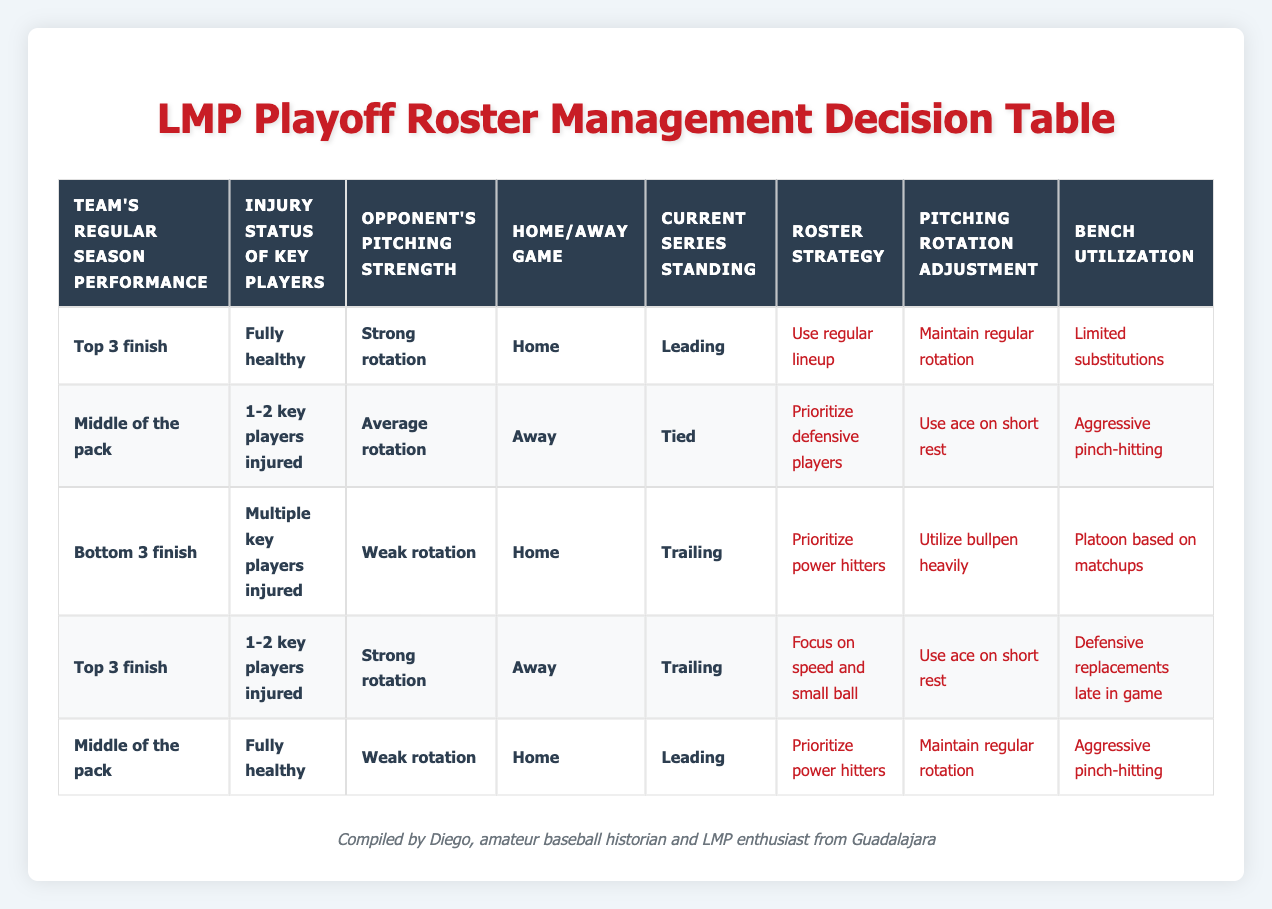What roster strategy is recommended for a team that finished in the Top 3 and is fully healthy at home while leading in the series? According to the table, the team that fits this description should "Use regular lineup." This matches with the row indicating a Top 3 finish, fully healthy players, home game, and leading in the series.
Answer: Use regular lineup What adjustments should a middle-of-the-pack team with 1-2 key players injured make while playing away and tied in the series? The table indicates that this team should "Prioritize defensive players," "Use ace on short rest," and "Aggressive pinch-hitting." This can be found in the corresponding row for the middle of the pack with key injuries, playing away and tied.
Answer: Prioritize defensive players; Use ace on short rest; Aggressive pinch-hitting Is it true that a team with a weak pitching rotation that finished in the Bottom 3 and has multiple key injuries should prioritize power hitters? Yes, the table confirms this. The relevant row shows that teams in that situation should "Prioritize power hitters," which matches the specified conditions.
Answer: Yes If a team is trailing in the series but has a Top 3 finish and 1-2 key players injured, what should they focus on? The strategy for this situation, as shown in the table, is to "Focus on speed and small ball" given they are trailing. This corresponds to the conditions described for that row.
Answer: Focus on speed and small ball What is the recommended pitching rotation adjustment for a team playing at home with a weak rotation while leading in the series? The table indicates that in this case, the adjustment should be to "Maintain regular rotation." This can be found under the middle of the pack with healthy players and leading at home.
Answer: Maintain regular rotation How many actions are listed for the scenario involving a trailing team in the Bottom 3 with multiple key injuries at home against a weak rotation? The table has 3 actions for this scenario: "Prioritize power hitters," "Utilize bullpen heavily," and "Platoon based on matchups." This means there are a total of three specific actions for this situation.
Answer: 3 actions What happens if a team that finished in the Middle of the pack is fully healthy, facing a strong rotation at home and is tied? The table suggests that they will need to "Prioritize defensive players," "Use ace on short rest," and "Aggressive pinch-hitting," as indicated by the corresponding row for that condition.
Answer: Prioritize defensive players; Use ace on short rest; Aggressive pinch-hitting For a team that is leading in the series and has finished in the Bottom 3 with several injuries, what is the bench utilization recommendation? The table suggests that the bench utilization should be "Platoon based on matchups." This is evident in the row where the team is trailing but matches the conditions specified.
Answer: Platoon based on matchups 